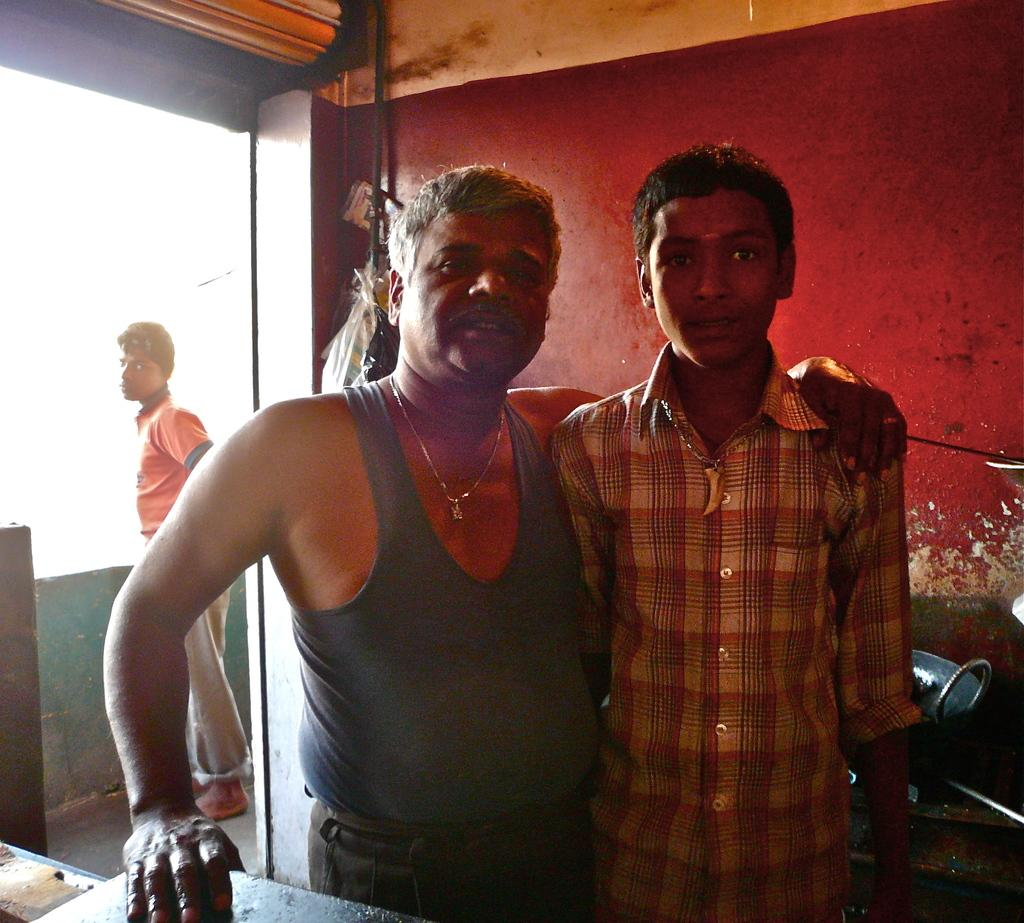Where was the image taken? The image was taken inside a room. How many people are in the image? There are three persons in the image. Can you describe the positioning of the people in the image? Two of the persons are in the front. What is one of the men wearing in the image? One man is wearing a chain around his neck. What color is the sheet of paper that the man is blowing on in the image? There is no sheet of paper or blowing action present in the image. 